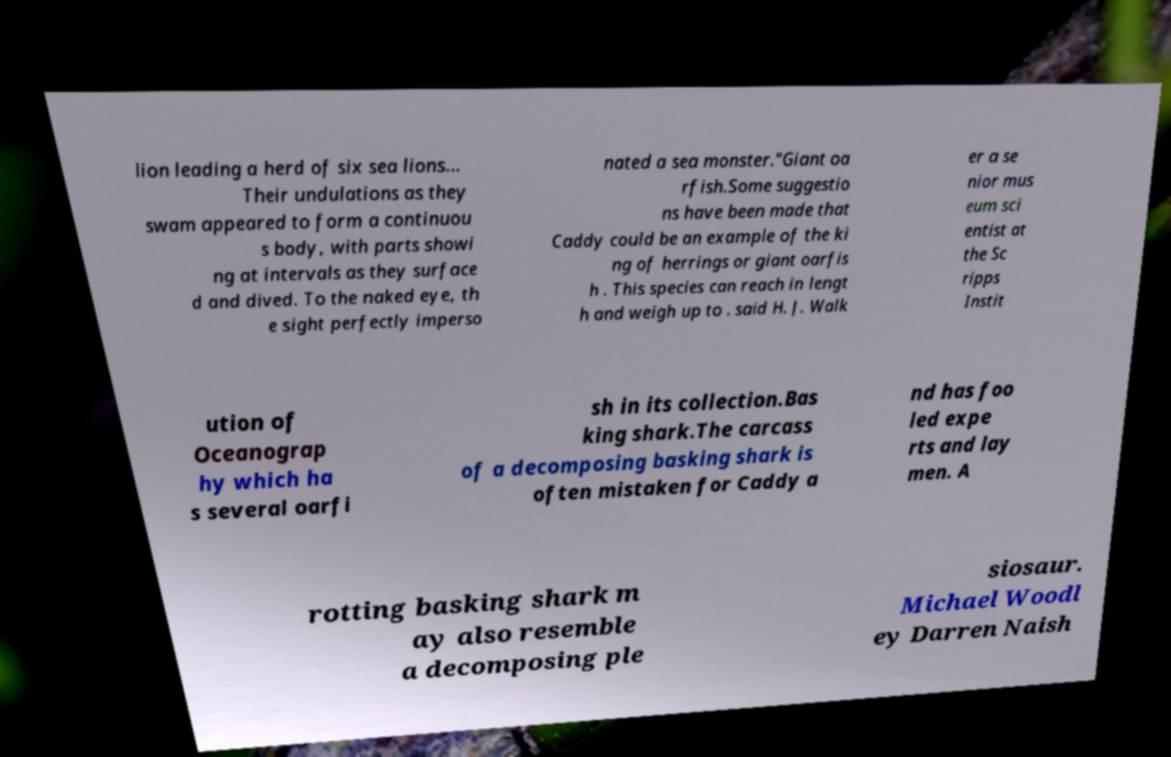What messages or text are displayed in this image? I need them in a readable, typed format. lion leading a herd of six sea lions... Their undulations as they swam appeared to form a continuou s body, with parts showi ng at intervals as they surface d and dived. To the naked eye, th e sight perfectly imperso nated a sea monster."Giant oa rfish.Some suggestio ns have been made that Caddy could be an example of the ki ng of herrings or giant oarfis h . This species can reach in lengt h and weigh up to . said H. J. Walk er a se nior mus eum sci entist at the Sc ripps Instit ution of Oceanograp hy which ha s several oarfi sh in its collection.Bas king shark.The carcass of a decomposing basking shark is often mistaken for Caddy a nd has foo led expe rts and lay men. A rotting basking shark m ay also resemble a decomposing ple siosaur. Michael Woodl ey Darren Naish 